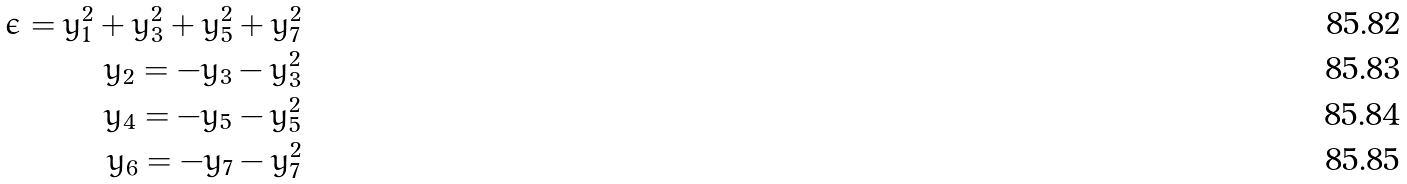Convert formula to latex. <formula><loc_0><loc_0><loc_500><loc_500>\epsilon = y _ { 1 } ^ { 2 } + y _ { 3 } ^ { 2 } + y _ { 5 } ^ { 2 } + y _ { 7 } ^ { 2 } \\ y _ { 2 } = - y _ { 3 } - y _ { 3 } ^ { 2 } \\ y _ { 4 } = - y _ { 5 } - y _ { 5 } ^ { 2 } \\ y _ { 6 } = - y _ { 7 } - y _ { 7 } ^ { 2 }</formula> 